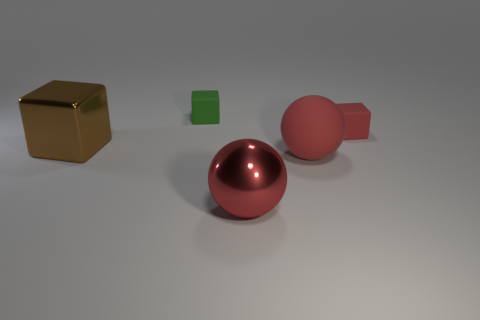Is the material of the tiny cube on the left side of the shiny sphere the same as the red cube?
Your answer should be compact. Yes. How many metal things have the same shape as the small green matte thing?
Provide a short and direct response. 1. What number of big things are brown objects or green things?
Provide a succinct answer. 1. There is a cube that is to the right of the tiny green cube; does it have the same color as the metal ball?
Your answer should be very brief. Yes. Do the tiny matte cube in front of the green matte object and the large metallic thing that is in front of the metal block have the same color?
Offer a very short reply. Yes. Are there any red things made of the same material as the small green cube?
Ensure brevity in your answer.  Yes. What number of blue objects are big objects or large spheres?
Your response must be concise. 0. Are there more small things behind the green matte object than green shiny things?
Provide a short and direct response. No. Do the brown metallic block and the red shiny object have the same size?
Offer a terse response. Yes. What is the color of the small thing that is made of the same material as the red cube?
Provide a short and direct response. Green. 